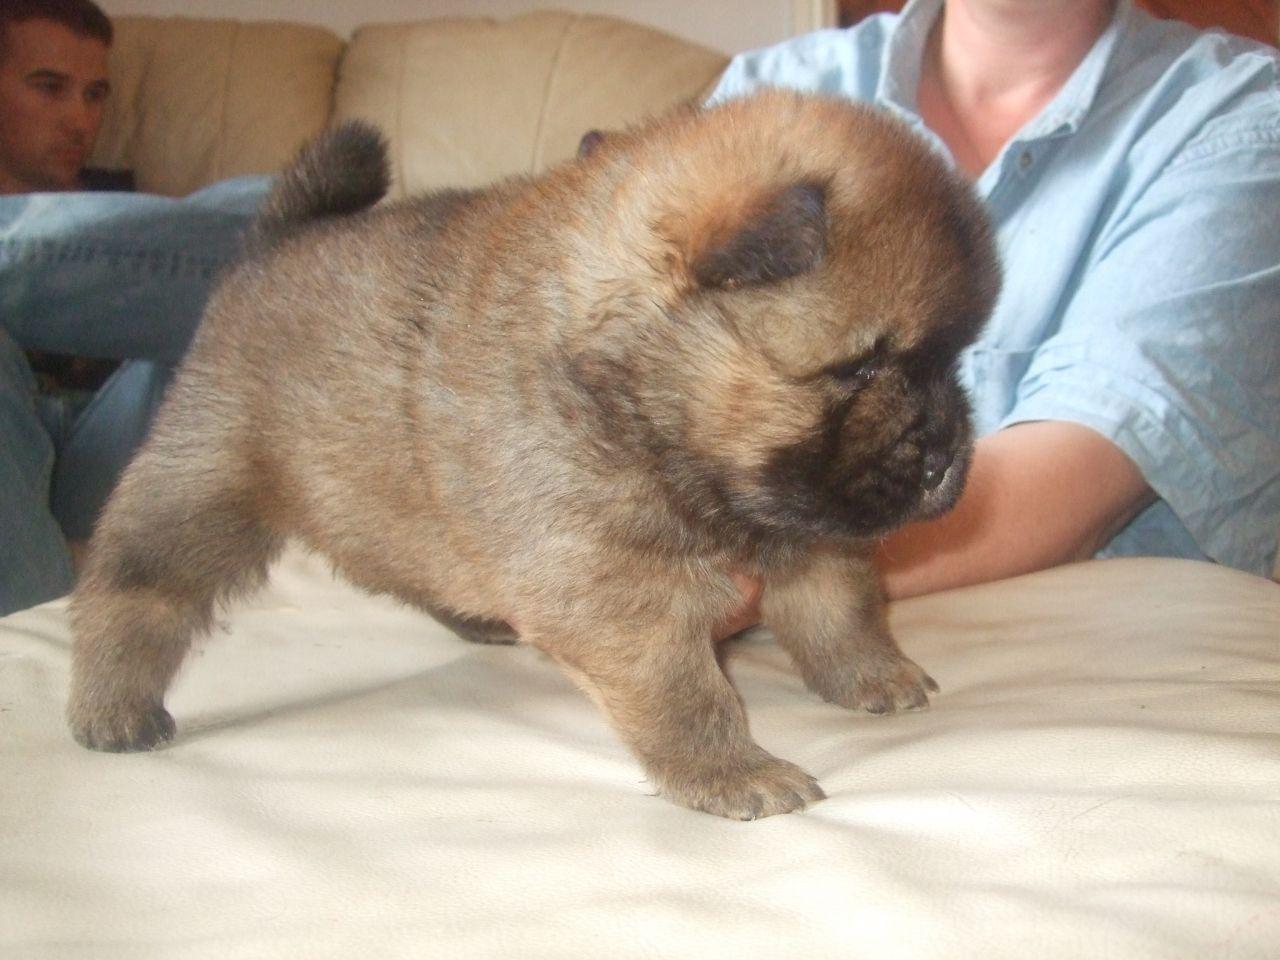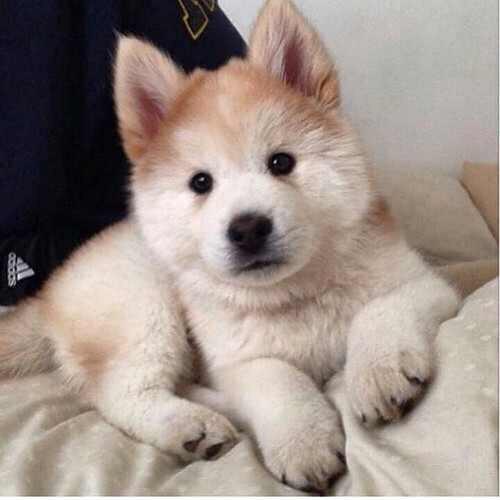The first image is the image on the left, the second image is the image on the right. Considering the images on both sides, is "An image shows at least one chow dog in a basket-like container." valid? Answer yes or no. No. The first image is the image on the left, the second image is the image on the right. Given the left and right images, does the statement "There is at least one human in one of the images." hold true? Answer yes or no. Yes. 